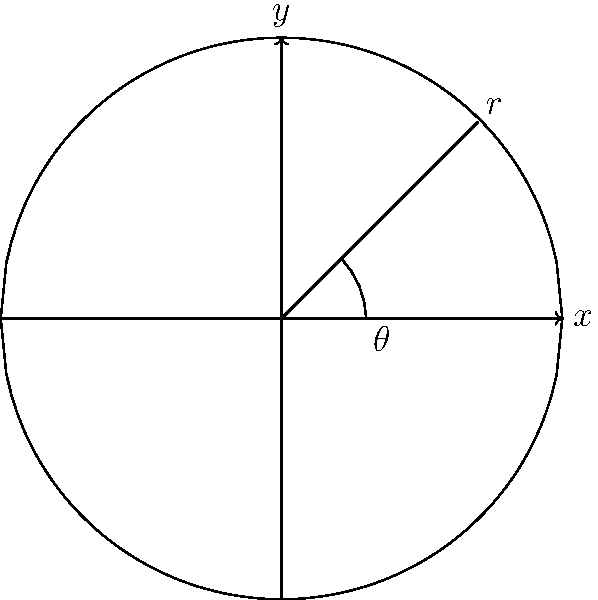For the upcoming Sandbanks Regatta, you're designing an optimal sail shape. The sail can be modeled as a quarter-circle with radius $r$. Given that the wind force $F$ on the sail is proportional to the sail's area $A$ and the square of the wind speed $v$, which varies with height $h$ according to the function $v(h) = 10\sqrt{h}$ (where $h$ is in meters and $v$ is in m/s), find the optimal radius $r$ of the sail to maximize the wind force. Assume the sail's base is at sea level and its cost is proportional to its perimeter. Let's approach this step-by-step:

1) The area of a quarter-circle is given by $A = \frac{\pi r^2}{4}$.

2) The wind force $F$ is proportional to $A$ and $v^2$. We can write this as:
   $F \propto A \cdot v^2$

3) We need to integrate the force over the height of the sail:
   $F = k \int_0^r A \cdot v(h)^2 dh$, where $k$ is some constant.

4) Substituting the expressions for $A$ and $v(h)$:
   $F = k \frac{\pi r^2}{4} \int_0^r (10\sqrt{h})^2 dh = 25k\pi r^2 \int_0^r h dh$

5) Evaluating the integral:
   $F = 25k\pi r^2 [\frac{h^2}{2}]_0^r = \frac{25k\pi r^4}{4}$

6) To maximize $F$, we would normally differentiate and set to zero. However, we also need to consider the cost, which is proportional to the perimeter.

7) The perimeter of a quarter-circle is $P = r(\frac{\pi}{2} + 2)$

8) Let's define an efficiency $E$ as force per unit perimeter:
   $E = \frac{F}{P} = \frac{\frac{25k\pi r^4}{4}}{r(\frac{\pi}{2} + 2)} = \frac{25k\pi r^3}{4(\frac{\pi}{2} + 2)}$

9) To maximize $E$, we differentiate with respect to $r$ and set to zero:
   $\frac{dE}{dr} = \frac{75k\pi r^2}{4(\frac{\pi}{2} + 2)} = 0$

10) This is only zero when $r = 0$, which isn't a useful solution. This means that theoretically, the larger the sail, the more efficient it becomes.

11) In practice, the optimal size would be limited by other factors such as the size of the boat, the strength of the mast, or regatta regulations.
Answer: Theoretically, efficiency increases with sail size; practical limit depends on boat constraints and regatta rules. 